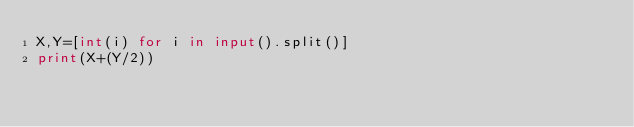<code> <loc_0><loc_0><loc_500><loc_500><_Python_>X,Y=[int(i) for i in input().split()]
print(X+(Y/2))</code> 